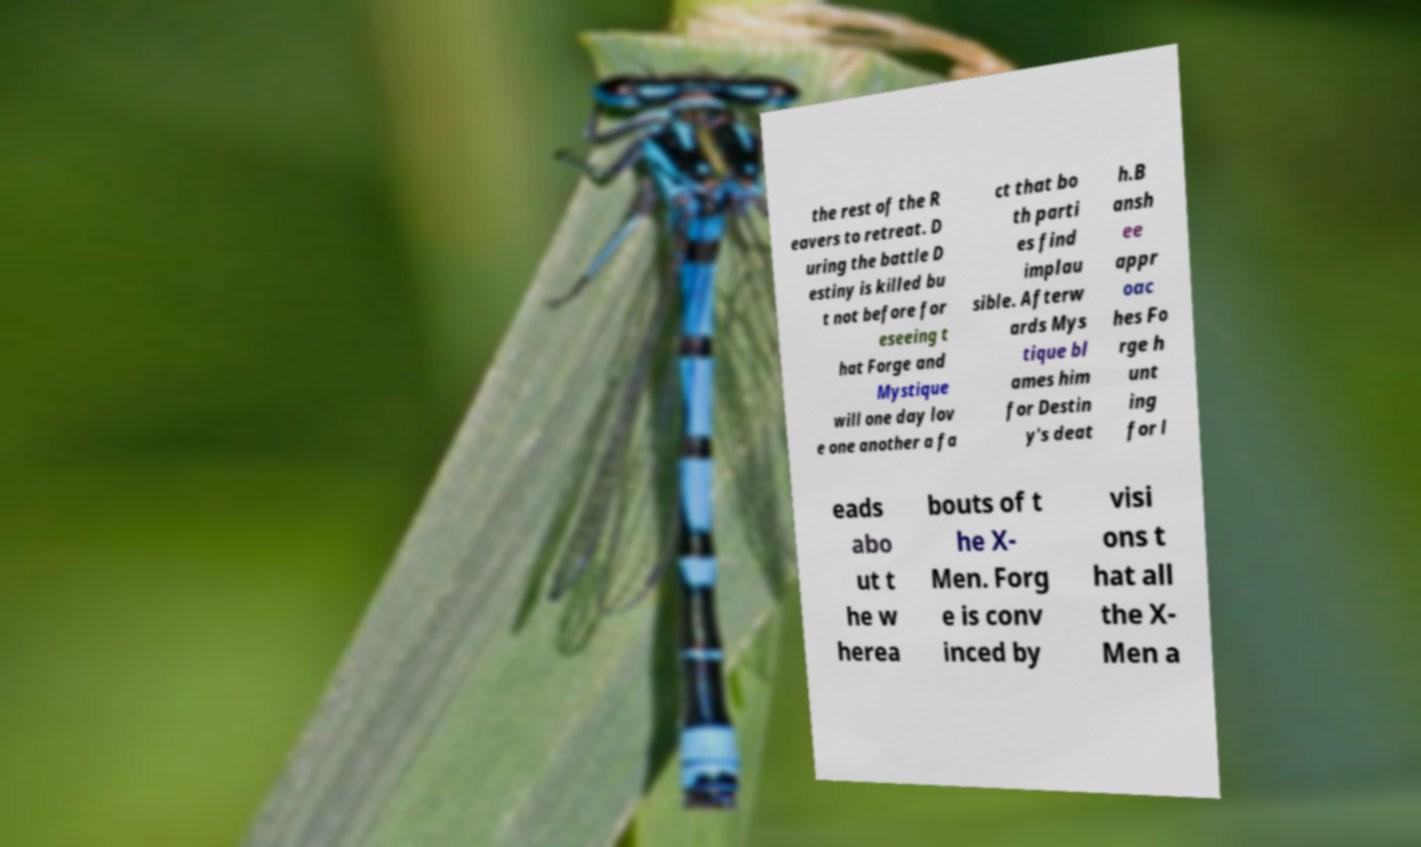Please identify and transcribe the text found in this image. the rest of the R eavers to retreat. D uring the battle D estiny is killed bu t not before for eseeing t hat Forge and Mystique will one day lov e one another a fa ct that bo th parti es find implau sible. Afterw ards Mys tique bl ames him for Destin y's deat h.B ansh ee appr oac hes Fo rge h unt ing for l eads abo ut t he w herea bouts of t he X- Men. Forg e is conv inced by visi ons t hat all the X- Men a 